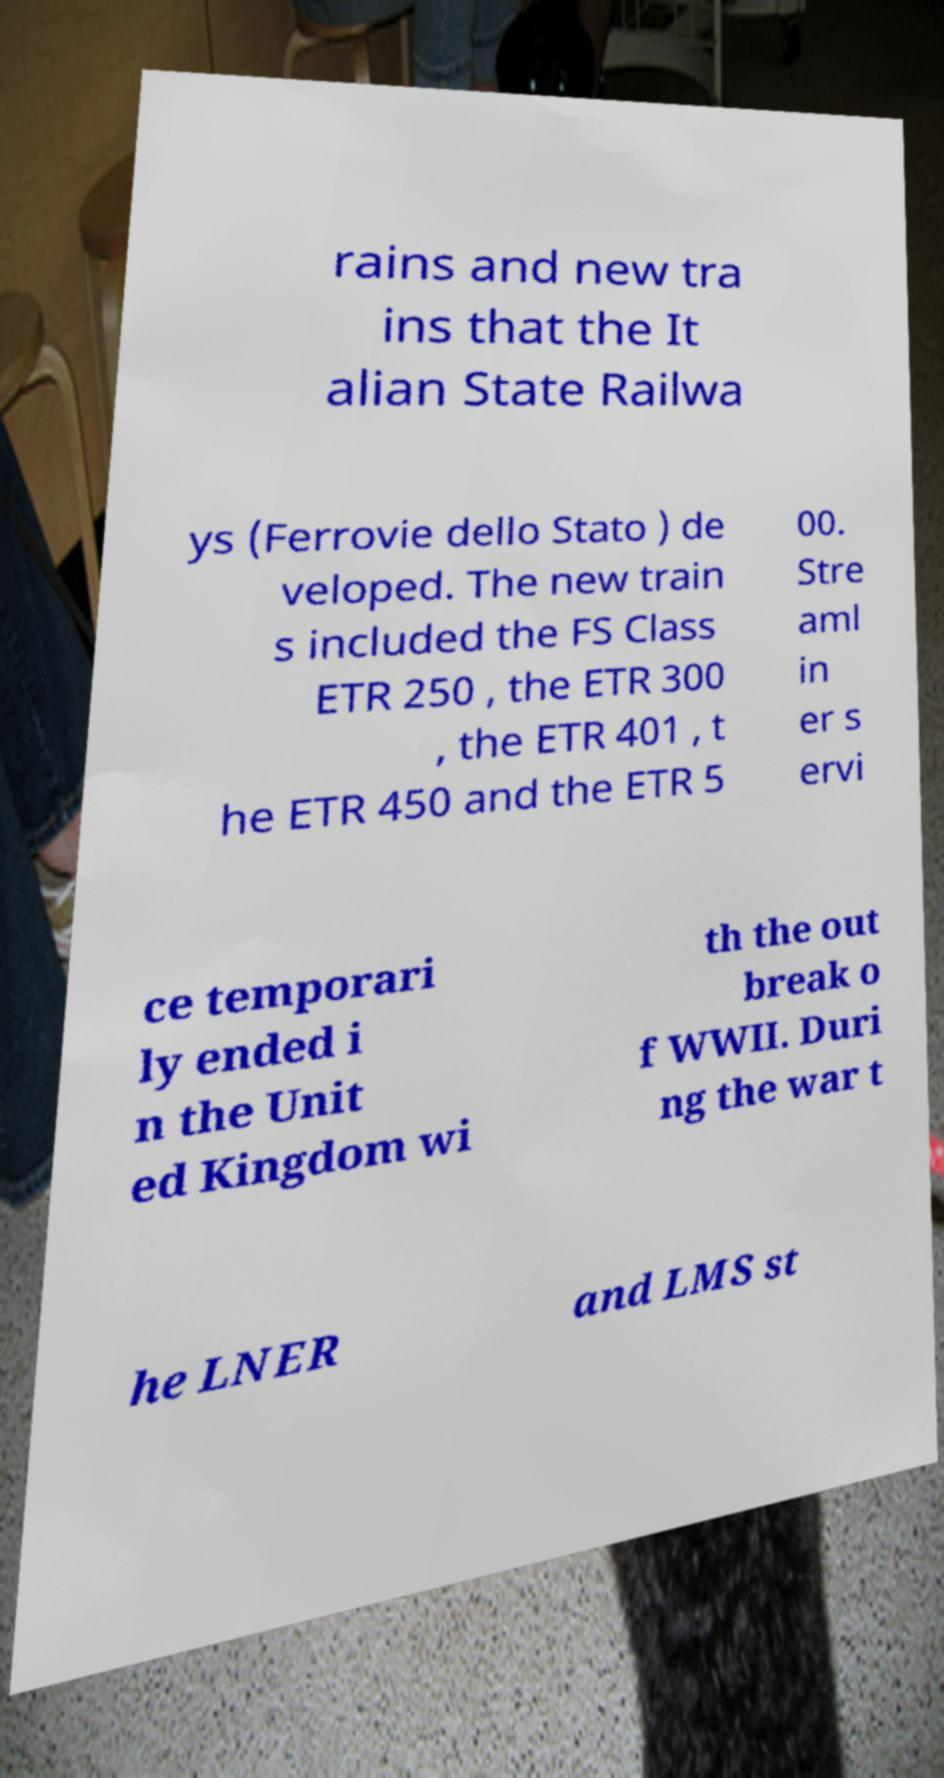I need the written content from this picture converted into text. Can you do that? rains and new tra ins that the It alian State Railwa ys (Ferrovie dello Stato ) de veloped. The new train s included the FS Class ETR 250 , the ETR 300 , the ETR 401 , t he ETR 450 and the ETR 5 00. Stre aml in er s ervi ce temporari ly ended i n the Unit ed Kingdom wi th the out break o f WWII. Duri ng the war t he LNER and LMS st 